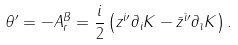<formula> <loc_0><loc_0><loc_500><loc_500>\theta ^ { \prime } = - A _ { r } ^ { B } = \frac { i } { 2 } \left ( z ^ { i \prime } \partial _ { i } K - \bar { z } ^ { \bar { \imath } \prime } \partial _ { \bar { \imath } } K \right ) .</formula> 